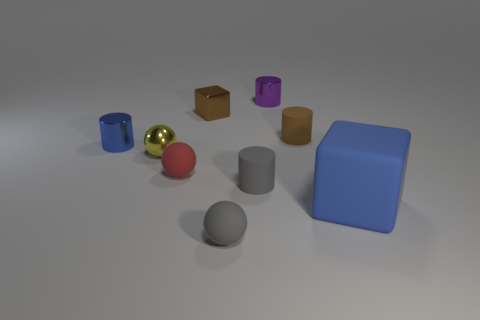Subtract all tiny matte spheres. How many spheres are left? 1 Subtract 2 cylinders. How many cylinders are left? 2 Subtract all yellow cylinders. Subtract all green spheres. How many cylinders are left? 4 Subtract all cylinders. How many objects are left? 5 Subtract all small metallic objects. Subtract all small gray matte spheres. How many objects are left? 4 Add 8 large blue blocks. How many large blue blocks are left? 9 Add 7 big red rubber balls. How many big red rubber balls exist? 7 Subtract 1 brown cylinders. How many objects are left? 8 